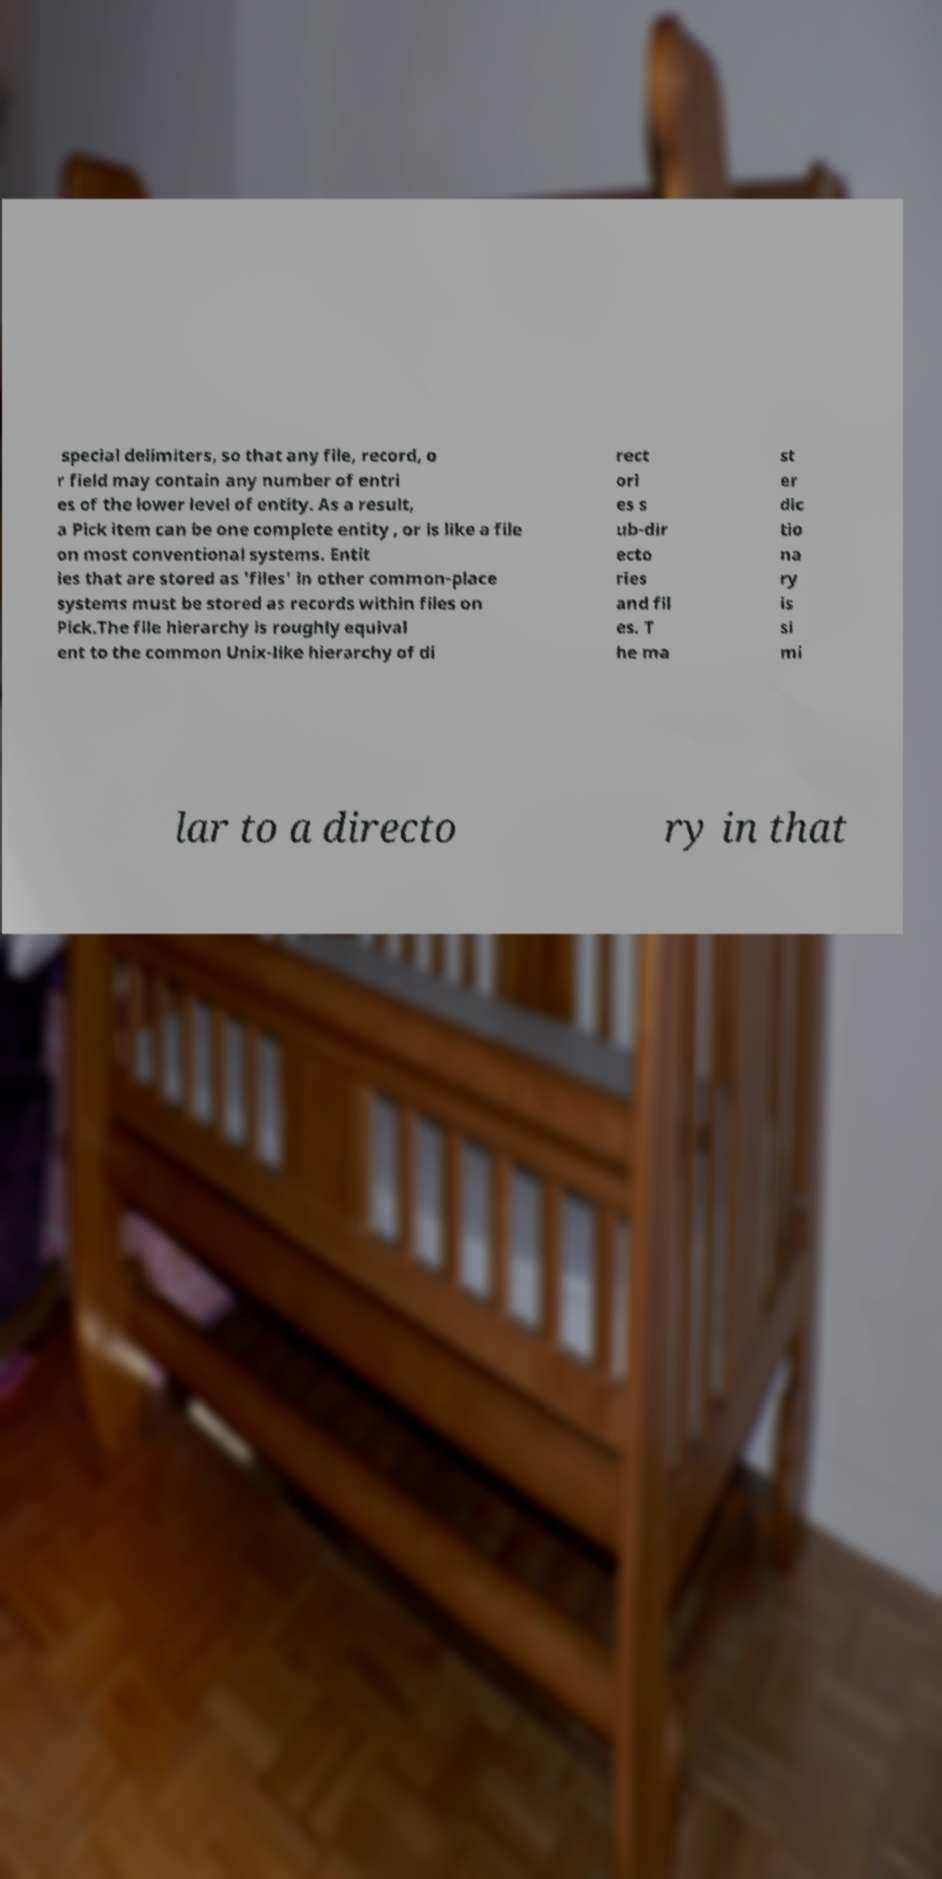I need the written content from this picture converted into text. Can you do that? special delimiters, so that any file, record, o r field may contain any number of entri es of the lower level of entity. As a result, a Pick item can be one complete entity , or is like a file on most conventional systems. Entit ies that are stored as 'files' in other common-place systems must be stored as records within files on Pick.The file hierarchy is roughly equival ent to the common Unix-like hierarchy of di rect ori es s ub-dir ecto ries and fil es. T he ma st er dic tio na ry is si mi lar to a directo ry in that 